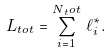<formula> <loc_0><loc_0><loc_500><loc_500>L _ { t o t } = \sum _ { i = 1 } ^ { N { _ { t } o t } } \, \ell _ { i } ^ { * } .</formula> 